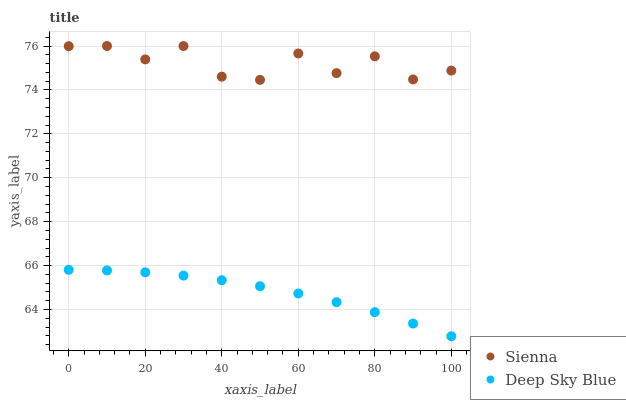Does Deep Sky Blue have the minimum area under the curve?
Answer yes or no. Yes. Does Sienna have the maximum area under the curve?
Answer yes or no. Yes. Does Deep Sky Blue have the maximum area under the curve?
Answer yes or no. No. Is Deep Sky Blue the smoothest?
Answer yes or no. Yes. Is Sienna the roughest?
Answer yes or no. Yes. Is Deep Sky Blue the roughest?
Answer yes or no. No. Does Deep Sky Blue have the lowest value?
Answer yes or no. Yes. Does Sienna have the highest value?
Answer yes or no. Yes. Does Deep Sky Blue have the highest value?
Answer yes or no. No. Is Deep Sky Blue less than Sienna?
Answer yes or no. Yes. Is Sienna greater than Deep Sky Blue?
Answer yes or no. Yes. Does Deep Sky Blue intersect Sienna?
Answer yes or no. No. 